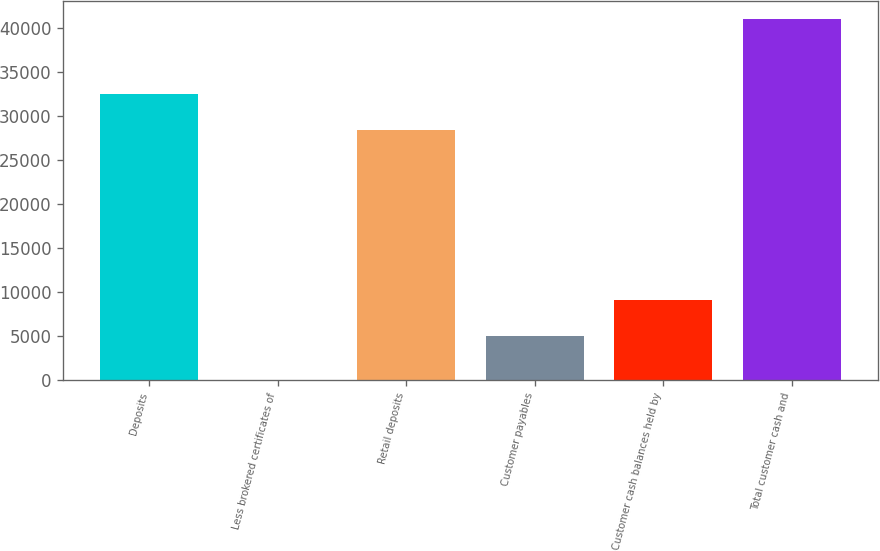<chart> <loc_0><loc_0><loc_500><loc_500><bar_chart><fcel>Deposits<fcel>Less brokered certificates of<fcel>Retail deposits<fcel>Customer payables<fcel>Customer cash balances held by<fcel>Total customer cash and<nl><fcel>32479.2<fcel>11.2<fcel>28381.3<fcel>4964.9<fcel>9062.82<fcel>40990.4<nl></chart> 